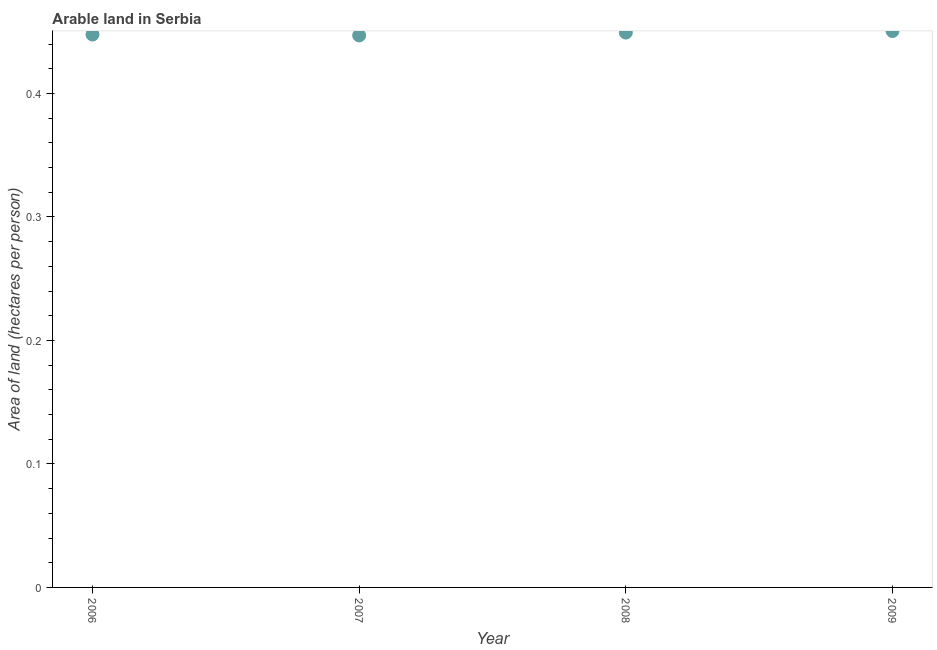What is the area of arable land in 2007?
Offer a terse response. 0.45. Across all years, what is the maximum area of arable land?
Your answer should be compact. 0.45. Across all years, what is the minimum area of arable land?
Provide a succinct answer. 0.45. In which year was the area of arable land maximum?
Keep it short and to the point. 2009. What is the sum of the area of arable land?
Provide a short and direct response. 1.79. What is the difference between the area of arable land in 2008 and 2009?
Offer a terse response. -0. What is the average area of arable land per year?
Offer a very short reply. 0.45. What is the median area of arable land?
Provide a short and direct response. 0.45. Do a majority of the years between 2007 and 2006 (inclusive) have area of arable land greater than 0.38000000000000006 hectares per person?
Provide a succinct answer. No. What is the ratio of the area of arable land in 2008 to that in 2009?
Provide a short and direct response. 1. Is the area of arable land in 2007 less than that in 2009?
Offer a very short reply. Yes. What is the difference between the highest and the second highest area of arable land?
Make the answer very short. 0. What is the difference between the highest and the lowest area of arable land?
Provide a succinct answer. 0. Does the area of arable land monotonically increase over the years?
Keep it short and to the point. No. How many years are there in the graph?
Give a very brief answer. 4. Does the graph contain grids?
Offer a terse response. No. What is the title of the graph?
Offer a terse response. Arable land in Serbia. What is the label or title of the Y-axis?
Keep it short and to the point. Area of land (hectares per person). What is the Area of land (hectares per person) in 2006?
Provide a succinct answer. 0.45. What is the Area of land (hectares per person) in 2007?
Provide a short and direct response. 0.45. What is the Area of land (hectares per person) in 2008?
Ensure brevity in your answer.  0.45. What is the Area of land (hectares per person) in 2009?
Provide a short and direct response. 0.45. What is the difference between the Area of land (hectares per person) in 2006 and 2007?
Make the answer very short. 0. What is the difference between the Area of land (hectares per person) in 2006 and 2008?
Provide a succinct answer. -0. What is the difference between the Area of land (hectares per person) in 2006 and 2009?
Your response must be concise. -0. What is the difference between the Area of land (hectares per person) in 2007 and 2008?
Ensure brevity in your answer.  -0. What is the difference between the Area of land (hectares per person) in 2007 and 2009?
Provide a short and direct response. -0. What is the difference between the Area of land (hectares per person) in 2008 and 2009?
Ensure brevity in your answer.  -0. What is the ratio of the Area of land (hectares per person) in 2006 to that in 2007?
Give a very brief answer. 1. What is the ratio of the Area of land (hectares per person) in 2006 to that in 2008?
Your answer should be very brief. 1. What is the ratio of the Area of land (hectares per person) in 2007 to that in 2008?
Your answer should be compact. 0.99. What is the ratio of the Area of land (hectares per person) in 2008 to that in 2009?
Make the answer very short. 1. 